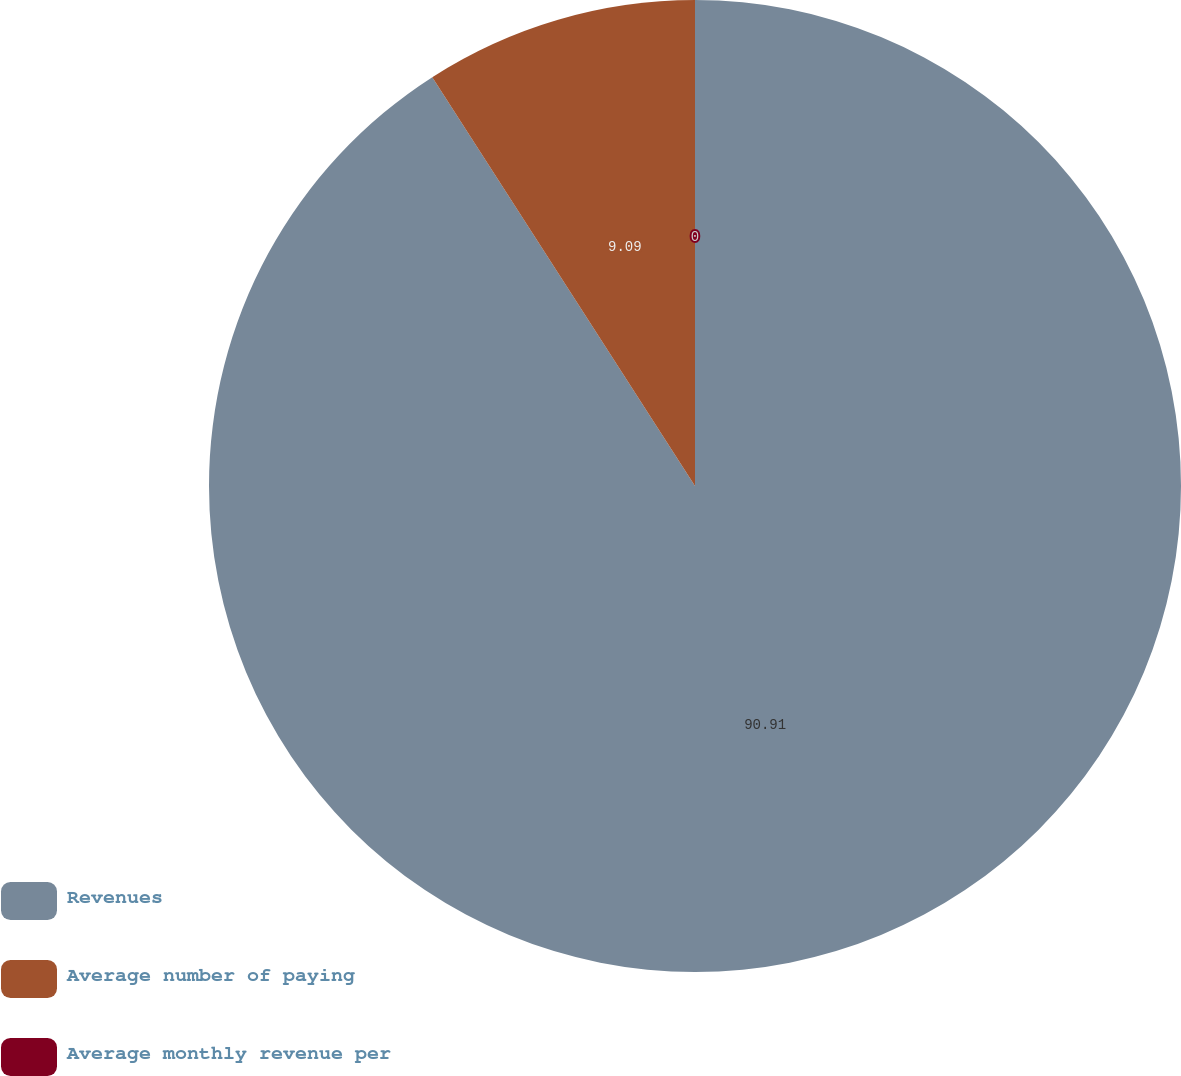Convert chart to OTSL. <chart><loc_0><loc_0><loc_500><loc_500><pie_chart><fcel>Revenues<fcel>Average number of paying<fcel>Average monthly revenue per<nl><fcel>90.91%<fcel>9.09%<fcel>0.0%<nl></chart> 